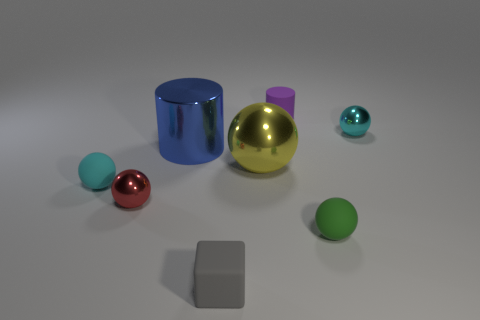Can you describe the composition of objects in terms of geometry? Certainly! The image showcases basic geometrical shapes: cylinders, spheres, and a cube. Each object has a different size and color, which makes the composition visually interesting and well-balanced. Do the objects have any real-world scale reference? Without a common reference object like a coin or a ruler, it’s difficult to ascertain the exact scale; however, the objects appear similar in size to what you might find on a desktop or a display shelf. 